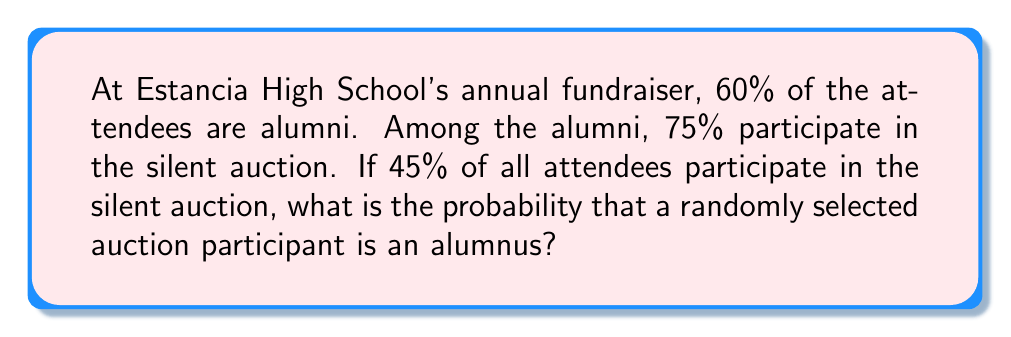What is the answer to this math problem? Let's approach this problem using conditional probability. We'll define the following events:

A: The selected person is an alumnus
B: The selected person participates in the auction

We're given the following information:
$P(A) = 0.60$ (60% of attendees are alumni)
$P(B|A) = 0.75$ (75% of alumni participate in the auction)
$P(B) = 0.45$ (45% of all attendees participate in the auction)

We need to find $P(A|B)$, the probability that a randomly selected auction participant is an alumnus.

We can use Bayes' Theorem:

$$P(A|B) = \frac{P(B|A) \cdot P(A)}{P(B)}$$

Substituting the values:

$$P(A|B) = \frac{0.75 \cdot 0.60}{0.45}$$

Calculating:

$$P(A|B) = \frac{0.45}{0.45} = 1$$

Therefore, the probability that a randomly selected auction participant is an alumnus is 1, or 100%.

To verify this result, we can calculate the total probability of auction participation:

$P(B) = P(B|A) \cdot P(A) + P(B|\text{not A}) \cdot P(\text{not A})$

$0.45 = 0.75 \cdot 0.60 + P(B|\text{not A}) \cdot 0.40$

$0.45 = 0.45 + P(B|\text{not A}) \cdot 0.40$

$P(B|\text{not A}) \cdot 0.40 = 0$

$P(B|\text{not A}) = 0$

This confirms that all auction participants must be alumni.
Answer: $P(A|B) = 1$ or 100% 